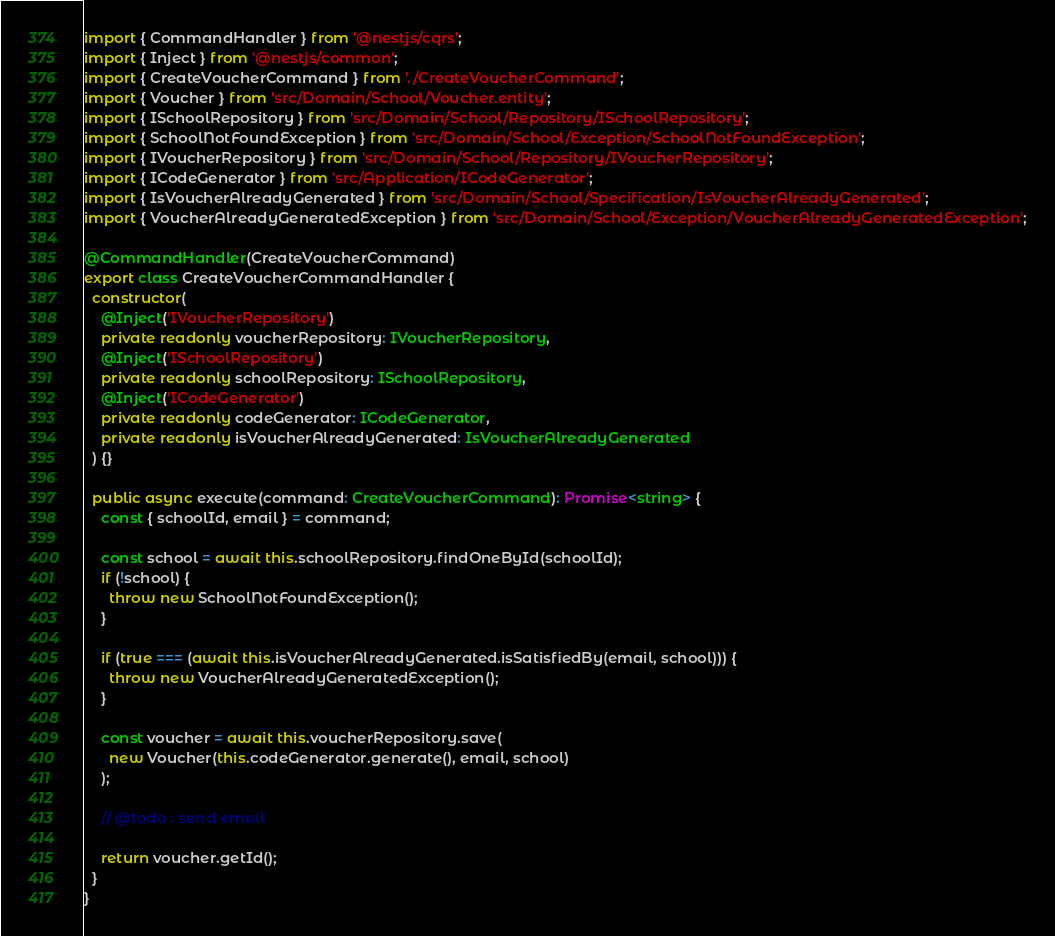Convert code to text. <code><loc_0><loc_0><loc_500><loc_500><_TypeScript_>import { CommandHandler } from '@nestjs/cqrs';
import { Inject } from '@nestjs/common';
import { CreateVoucherCommand } from './CreateVoucherCommand';
import { Voucher } from 'src/Domain/School/Voucher.entity';
import { ISchoolRepository } from 'src/Domain/School/Repository/ISchoolRepository';
import { SchoolNotFoundException } from 'src/Domain/School/Exception/SchoolNotFoundException';
import { IVoucherRepository } from 'src/Domain/School/Repository/IVoucherRepository';
import { ICodeGenerator } from 'src/Application/ICodeGenerator';
import { IsVoucherAlreadyGenerated } from 'src/Domain/School/Specification/IsVoucherAlreadyGenerated';
import { VoucherAlreadyGeneratedException } from 'src/Domain/School/Exception/VoucherAlreadyGeneratedException';

@CommandHandler(CreateVoucherCommand)
export class CreateVoucherCommandHandler {
  constructor(
    @Inject('IVoucherRepository')
    private readonly voucherRepository: IVoucherRepository,
    @Inject('ISchoolRepository')
    private readonly schoolRepository: ISchoolRepository,
    @Inject('ICodeGenerator')
    private readonly codeGenerator: ICodeGenerator,
    private readonly isVoucherAlreadyGenerated: IsVoucherAlreadyGenerated
  ) {}

  public async execute(command: CreateVoucherCommand): Promise<string> {
    const { schoolId, email } = command;

    const school = await this.schoolRepository.findOneById(schoolId);
    if (!school) {
      throw new SchoolNotFoundException();
    }

    if (true === (await this.isVoucherAlreadyGenerated.isSatisfiedBy(email, school))) {
      throw new VoucherAlreadyGeneratedException();
    }

    const voucher = await this.voucherRepository.save(
      new Voucher(this.codeGenerator.generate(), email, school)
    );

    // @todo : send email

    return voucher.getId();
  }
}
</code> 